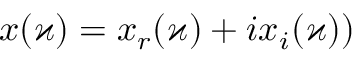<formula> <loc_0><loc_0><loc_500><loc_500>x ( \varkappa ) = x _ { r } ( \varkappa ) + i x _ { i } ( \varkappa ) )</formula> 